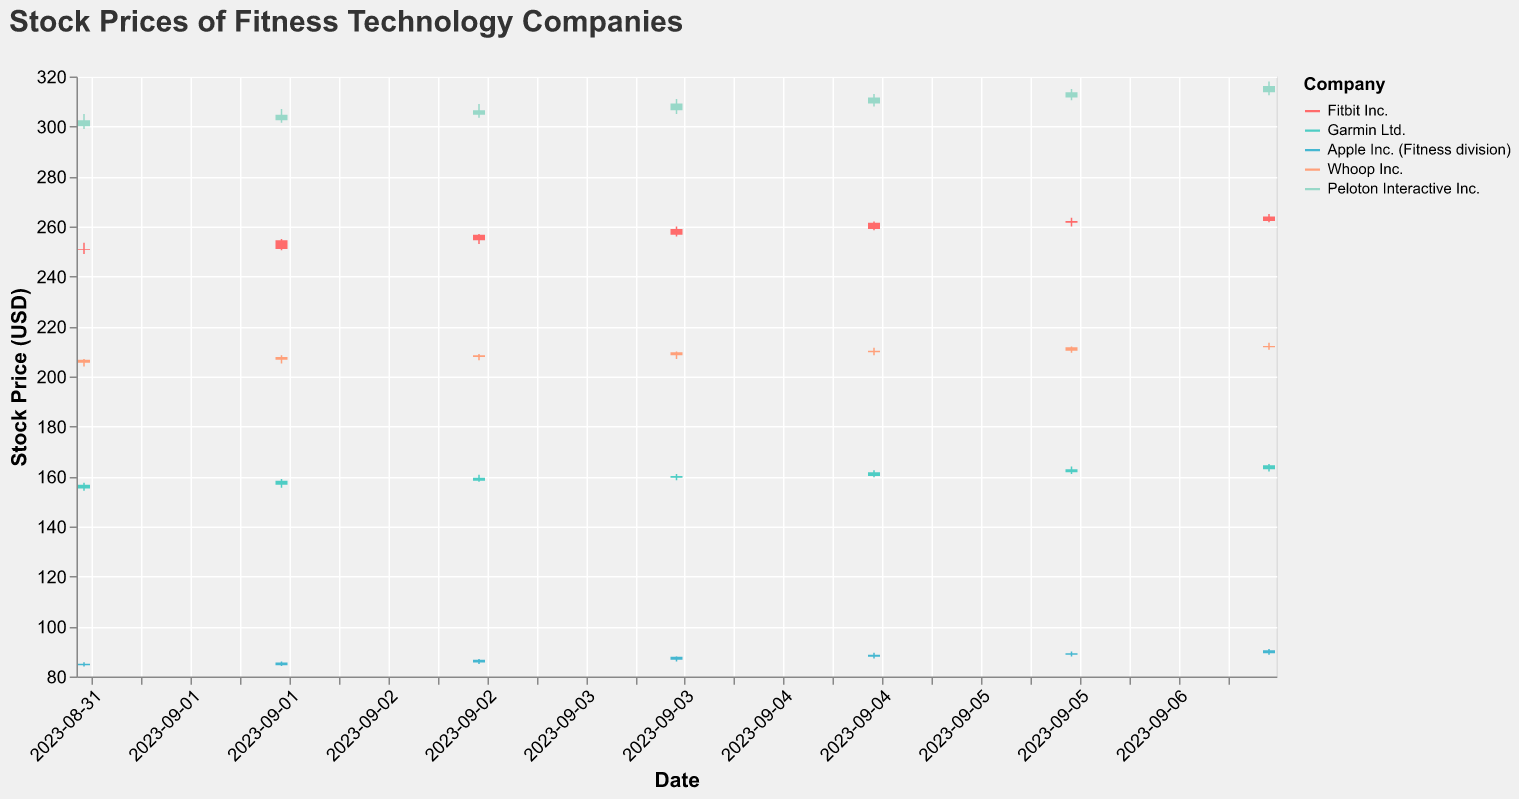Which company has the highest closing stock price on September 7, 2023? To answer this, we need to look at the closing stock prices for each company on September 7, 2023. The companies and their closing prices are Fitbit Inc. (264.00), Garmin Ltd. (164.50), Apple Inc. (Fitness division) (90.50), Whoop Inc. (212.25), and Peloton Interactive Inc. (316.25). Peloton Interactive Inc. has the highest closing stock price.
Answer: Peloton Interactive Inc What is the average closing price of Garmin Ltd. from September 1 to September 7, 2023? To find the average, we sum the closing prices for Garmin Ltd.: 156.75, 158.30, 159.50, 160.20, 161.70, 162.90, and 164.50. The sum is 1123.85. Divide this by the number of days (7) to find the average: 1123.85 / 7 ≈ 160.55.
Answer: 160.55 Which company saw the largest increase in closing price from September 1 to September 7, 2023? Subtract the closing prices on September 1 from the closing prices on September 7 for each company. Fitbit Inc.: 264.00 - 251.00 = 13.00, Garmin Ltd.: 164.50 - 156.75 = 7.75, Apple Inc. (Fitness division): 90.50 - 84.50 = 6.00, Whoop Inc.: 212.25 - 206.75 = 5.50, Peloton Interactive Inc.: 316.25 - 302.50 = 13.75. Peloton Interactive Inc has the largest increase in closing price.
Answer: Peloton Interactive Inc On which day did Fitbit Inc. have the highest trading volume? Check the volume data for Fitbit Inc. for each day: 1050000, 1250000, 1150000, 1100000, 1300000, 1200000, 1400000. The highest trading volume for Fitbit Inc. is on September 7, 2023, with a volume of 1400000.
Answer: September 7, 2023 Compare the closing price of Apple Inc. (Fitness division) and Garmin Ltd. on September 5, 2023. Which one is higher and by how much? The closing price for Apple Inc. (Fitness division) on September 5 is 88.75, and for Garmin Ltd. it is 161.70. Subtracting the values, 161.70 - 88.75 = 72.95. Garmin Ltd.'s closing price is higher by 72.95.
Answer: Garmin Ltd. by 72.95 What is the range of closing prices for Whoop Inc. during the week? To find the range, identify the highest and lowest closing prices for the week. The closing prices are: 206.75, 207.80, 208.50, 209.75, 210.30, 211.75, and 212.25. The range is 212.25 - 206.75 = 5.50.
Answer: 5.50 Which company had the least variation in stock price from September 1 to September 7, 2023? Compute the difference between the highest and lowest closing prices for each company over the week. Fitbit Inc.: 264.00 - 251.00 = 13.00, Garmin Ltd.: 164.50 - 156.75 = 7.75, Apple Inc. (Fitness division): 90.50 - 84.50 = 6.00, Whoop Inc.: 212.25 - 206.75 = 5.50, Peloton Interactive Inc.: 316.25 - 302.50 = 13.75. Whoop Inc. has the least variation at 5.50.
Answer: Whoop Inc On which date did Peloton Interactive Inc. see the highest stock price for the week? Look at the high prices for each date for Peloton Interactive Inc.: 305.00, 307.00, 309.00, 311.00, 313.00, 315.00, and 318.00. The highest price is 318.00 on September 7, 2023.
Answer: September 7, 2023 